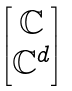Convert formula to latex. <formula><loc_0><loc_0><loc_500><loc_500>\begin{bmatrix} { \mathbb { C } } \\ { \mathbb { C } } ^ { d } \end{bmatrix}</formula> 